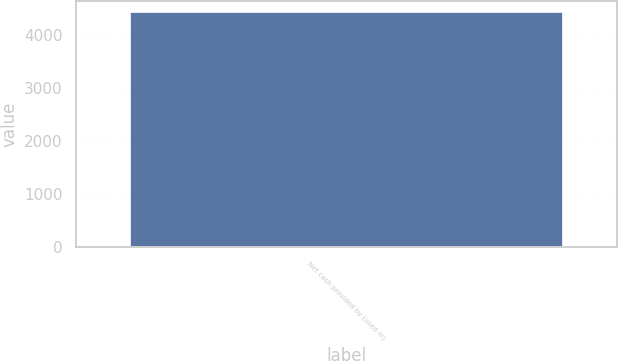Convert chart. <chart><loc_0><loc_0><loc_500><loc_500><bar_chart><fcel>Net cash provided by (used in)<nl><fcel>4432<nl></chart> 